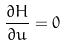Convert formula to latex. <formula><loc_0><loc_0><loc_500><loc_500>\frac { \partial H } { \partial u } = 0</formula> 